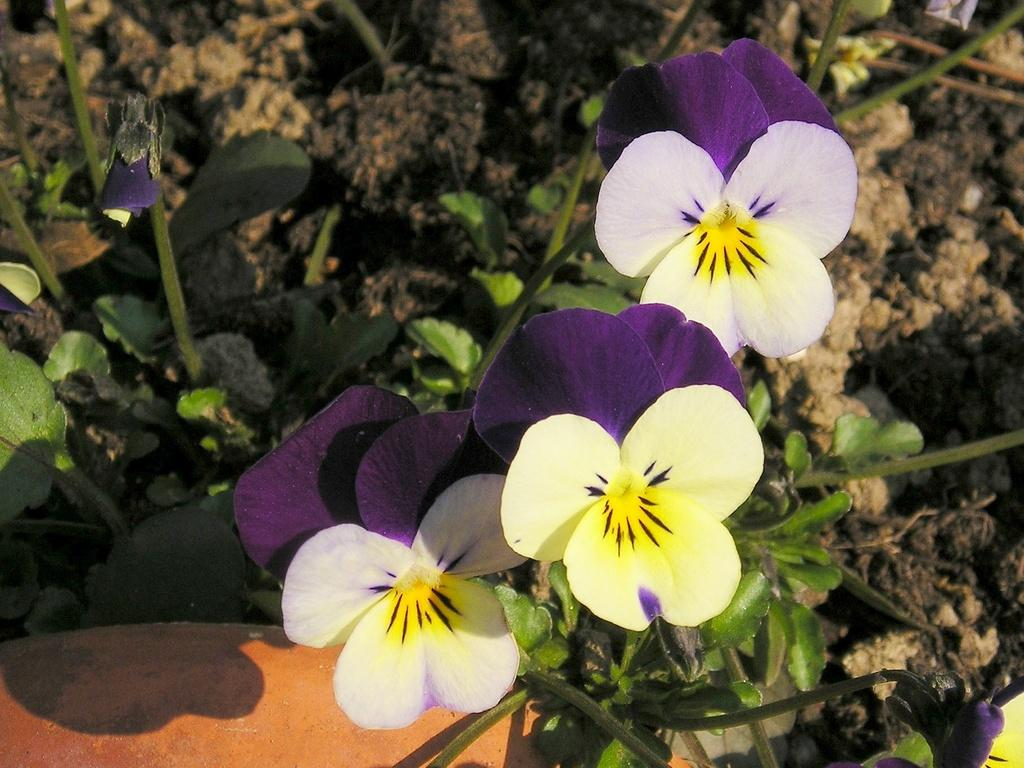What type of plant is present in the image? There are flowers on a plant in the image. Can you describe the environment in which the plant is situated? There is soil visible in the background of the image. What type of snake can be seen slithering near the plant in the image? There is no snake present in the image; it only features a plant with flowers and soil in the background. 